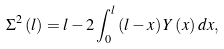<formula> <loc_0><loc_0><loc_500><loc_500>\Sigma ^ { 2 } \left ( l \right ) = l - 2 \int _ { 0 } ^ { l } \left ( l - x \right ) Y \left ( x \right ) d x ,</formula> 